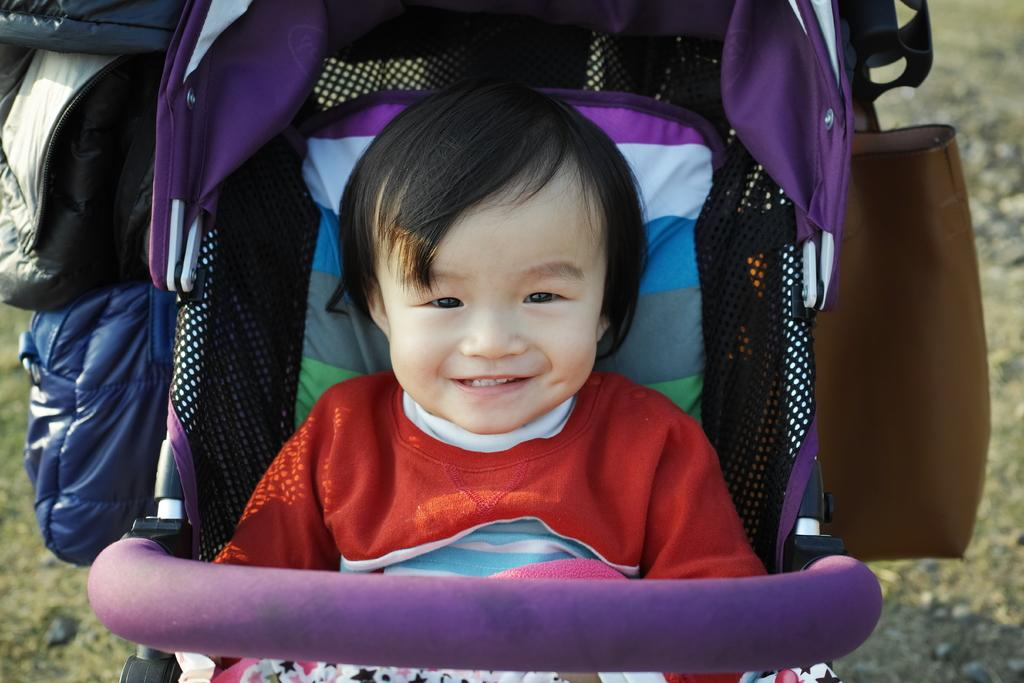What is the main subject of the image? There is a boy in a stroller in the image. What else can be seen in the image besides the boy in the stroller? There is a bag in the image. Can you describe the background of the image? The background of the image is blurred. What type of maid is attempting to fix the cable in the image? There is no maid or cable present in the image. 